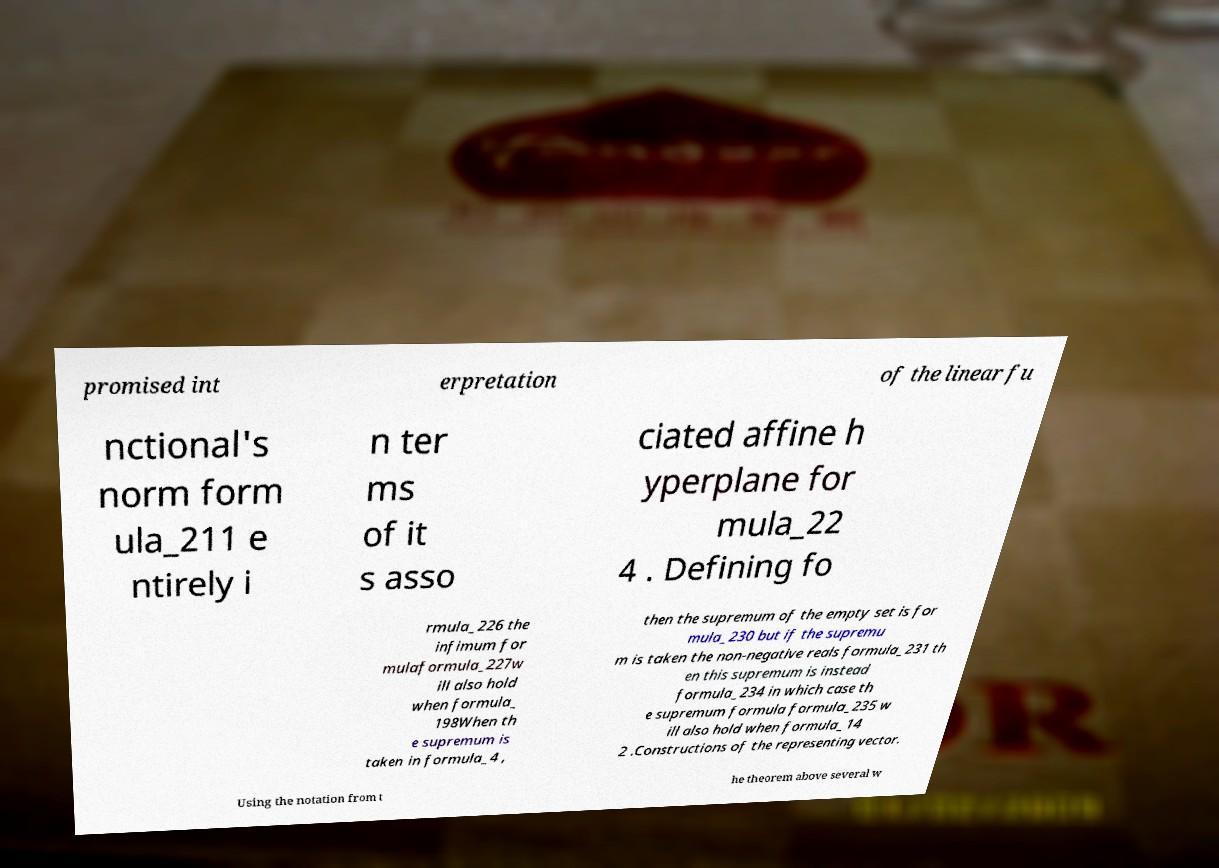Can you read and provide the text displayed in the image?This photo seems to have some interesting text. Can you extract and type it out for me? promised int erpretation of the linear fu nctional's norm form ula_211 e ntirely i n ter ms of it s asso ciated affine h yperplane for mula_22 4 . Defining fo rmula_226 the infimum for mulaformula_227w ill also hold when formula_ 198When th e supremum is taken in formula_4 , then the supremum of the empty set is for mula_230 but if the supremu m is taken the non-negative reals formula_231 th en this supremum is instead formula_234 in which case th e supremum formula formula_235 w ill also hold when formula_14 2 .Constructions of the representing vector. Using the notation from t he theorem above several w 